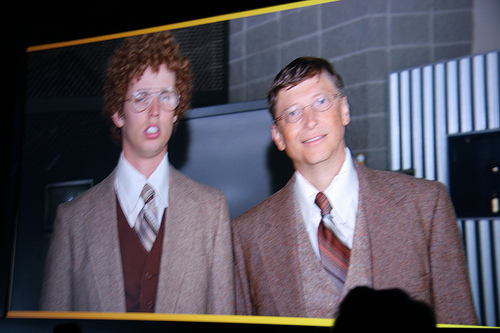<image>
Is there a napoleon dynamite in the movie? Yes. The napoleon dynamite is contained within or inside the movie, showing a containment relationship. Is there a bill gate in front of the friend? No. The bill gate is not in front of the friend. The spatial positioning shows a different relationship between these objects. 